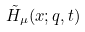<formula> <loc_0><loc_0><loc_500><loc_500>\tilde { H } _ { \mu } ( x ; q , t )</formula> 